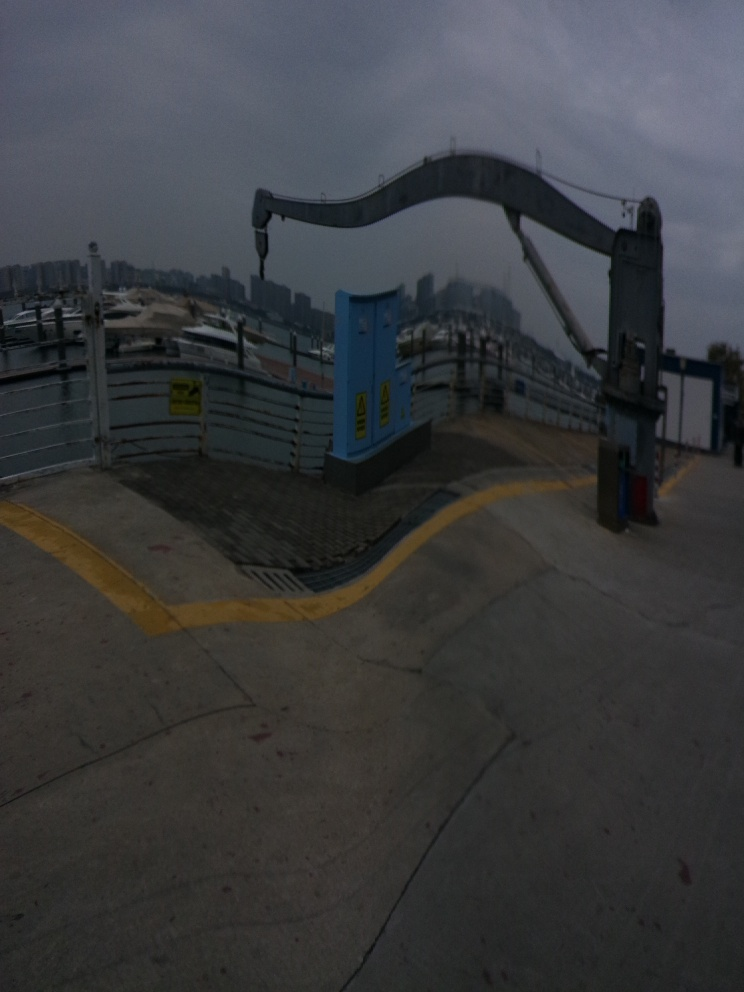Can you tell me more about the device in this picture? Certainly! The device appears to be an industrial crane or loading arm, often used in ports or construction sites to lift and move heavy objects. Its bright blue color stands out, which helps to identify its presence for safety. The machinery is at rest, with its arm extended out, and there's a small cabin at the base, likely for the operator's use. 